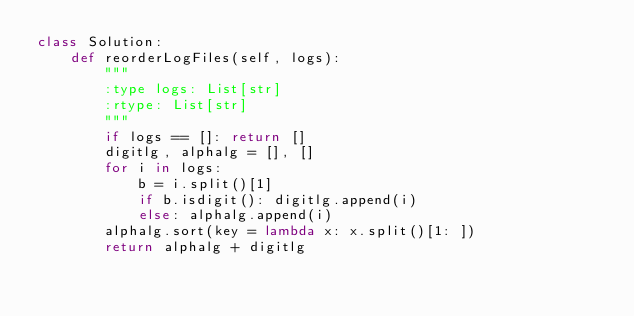Convert code to text. <code><loc_0><loc_0><loc_500><loc_500><_Python_>class Solution:
    def reorderLogFiles(self, logs):
        """
        :type logs: List[str]
        :rtype: List[str]
        """
        if logs == []: return []
        digitlg, alphalg = [], []
        for i in logs:
            b = i.split()[1]
            if b.isdigit(): digitlg.append(i)
            else: alphalg.append(i)
        alphalg.sort(key = lambda x: x.split()[1: ])
        return alphalg + digitlg</code> 